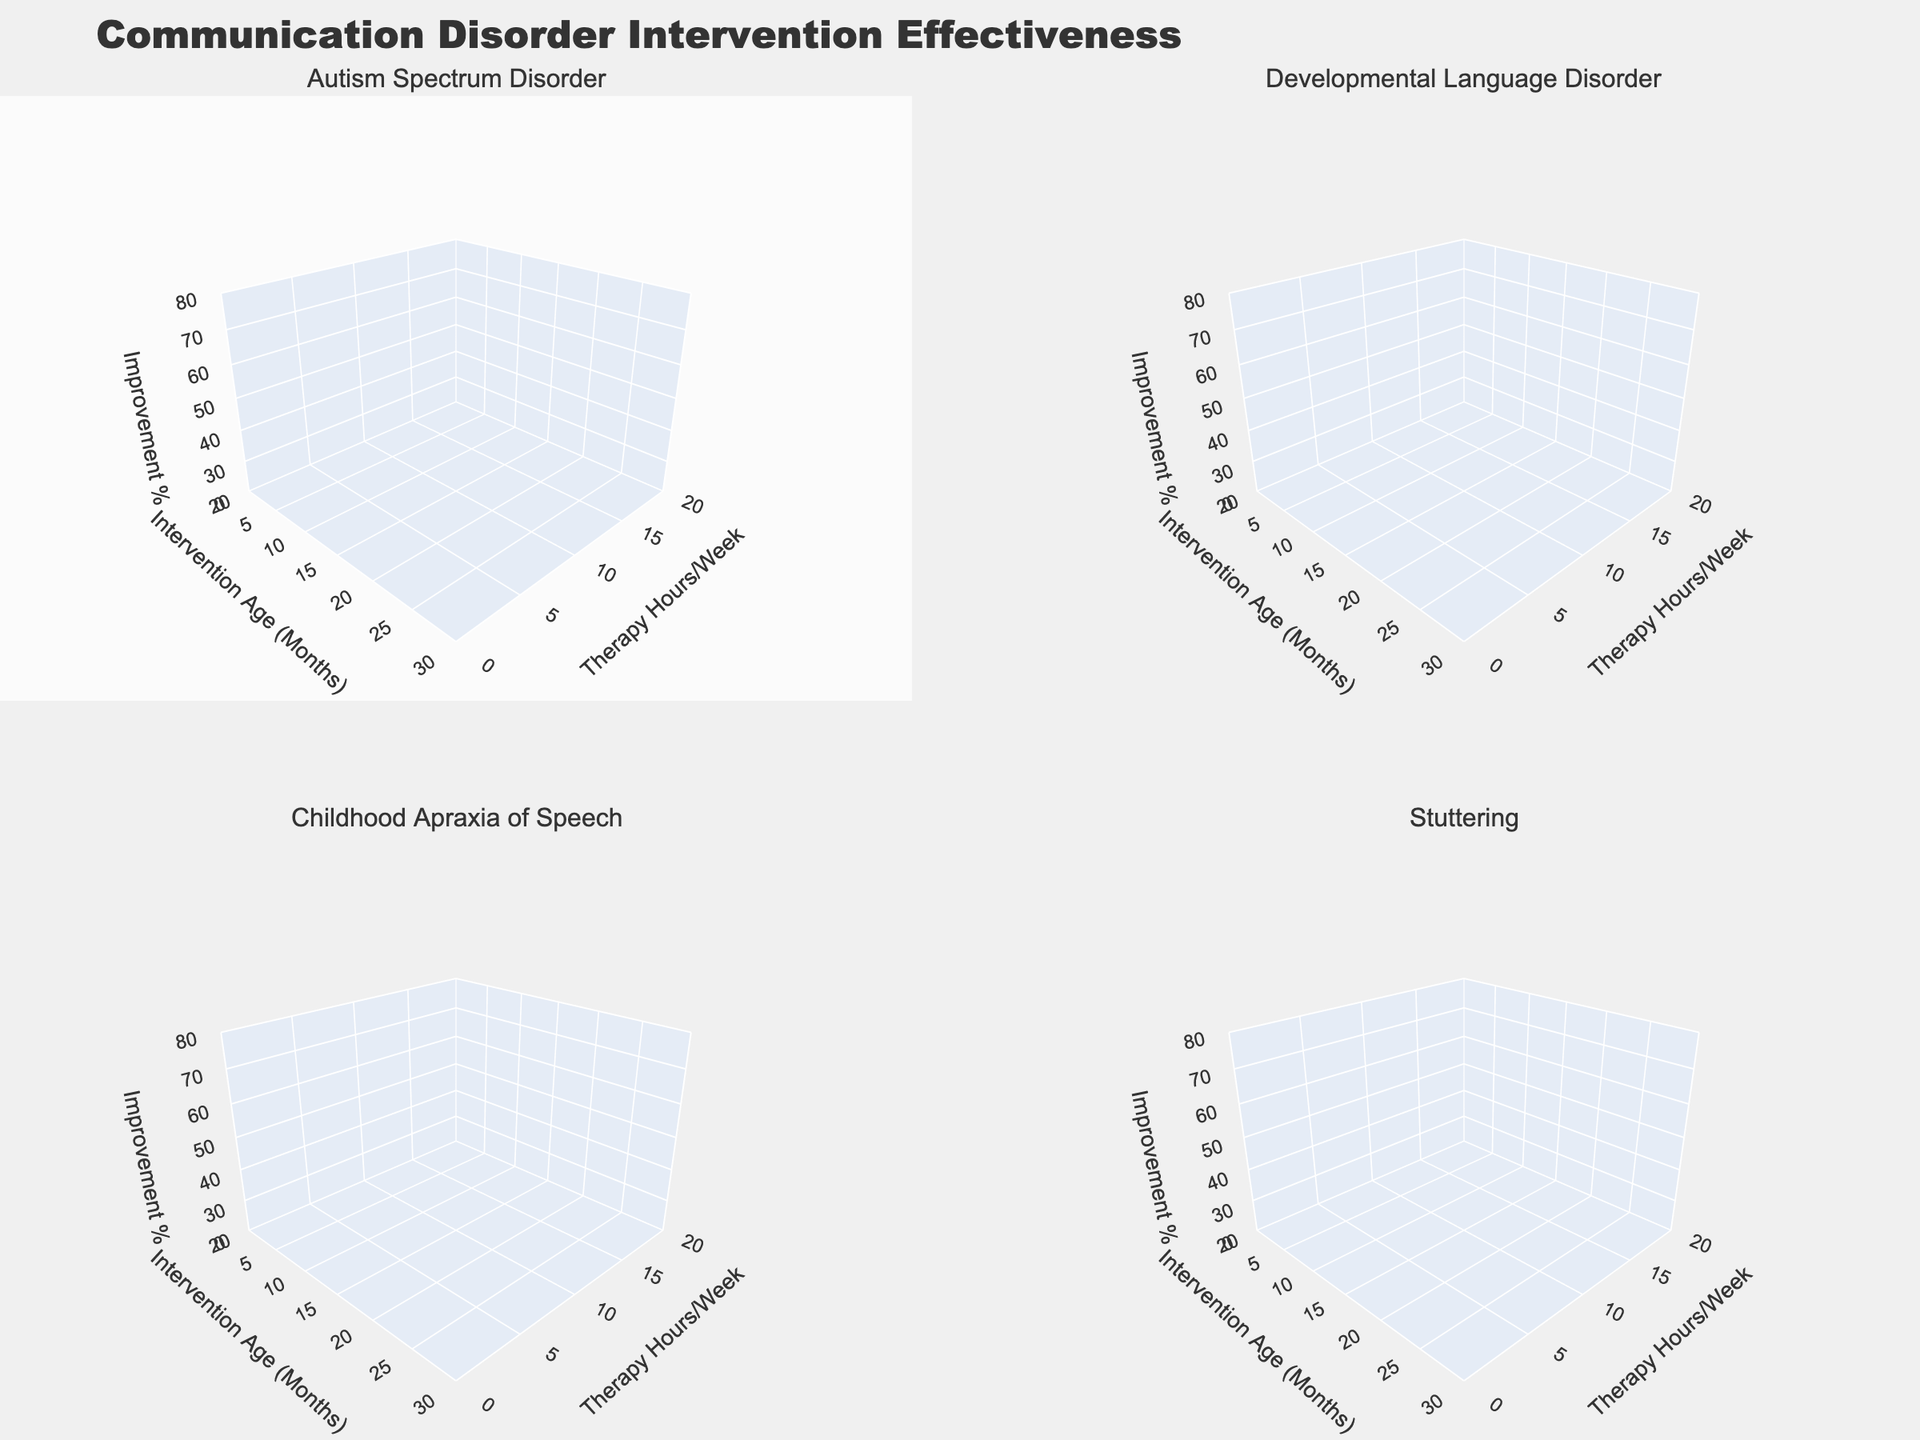What is the title of the figure? The title is prominently displayed at the top of the figure.
Answer: Communication Disorder Intervention Effectiveness What does the x-axis represent in all the subplots? Each subplot has the x-axis labeled consistently.
Answer: Intervention Age (Months) Which disorder is depicted in the bottom-left subplot? The subplot titles clearly indicate the disorder types.
Answer: Childhood Apraxia of Speech Which disorder has the highest therapy hours per week at 6 months of intervention age? By visually comparing the Therapy Hours/Week axis at 6 months, the subplot with the highest value can be identified.
Answer: Childhood Apraxia of Speech How does the improvement percentage change for Autism Spectrum Disorder when therapy hours per week are increased from 4 to 10 at 24 months of intervention age? First, locate the Autism Spectrum Disorder subplot, then compare the improvement percentages at 24 months for 4 hours/week and 10 hours/week.
Answer: It increases from 35% to 65% Which disorder shows the highest improvement percentage at 12 months intervention age, given 12 therapy hours per week? Locate each subplot and check the improvement percentage at 12 months and 12 hours/week for each disorder.
Answer: Developmental Language Disorder How does the improvement percentage for Developmental Language Disorder at 18 months and 8 hours per week compare to the improvement percentage for Stuttering at the same age and therapy intensity? Check the relevant subplots and compare the improvement percentages at the specified intervention age and therapy hours per week.
Answer: Developmental Language Disorder shows 50%, while Stuttering shows 40% Does increasing therapy hours per week always lead to higher improvement percentages across all disorders at 6 months of intervention? Compare the trends for 6 months intervention across all subplots and evaluate any deviations from this trend.
Answer: No, not always Are there any disorders for which the improvement percentage decreases despite an increase in therapy hours per week? A thorough observation of all subplots is required to identify any instances where improvement percentage decreases with increasing therapy hours.
Answer: No, improvement percentage generally increases or stays the same What is the range of improvement percentages for Stuttering based on the figure? By looking at the Stuttering subplot, identify the minimum and maximum improvement percentages.
Answer: 30% to 60% 